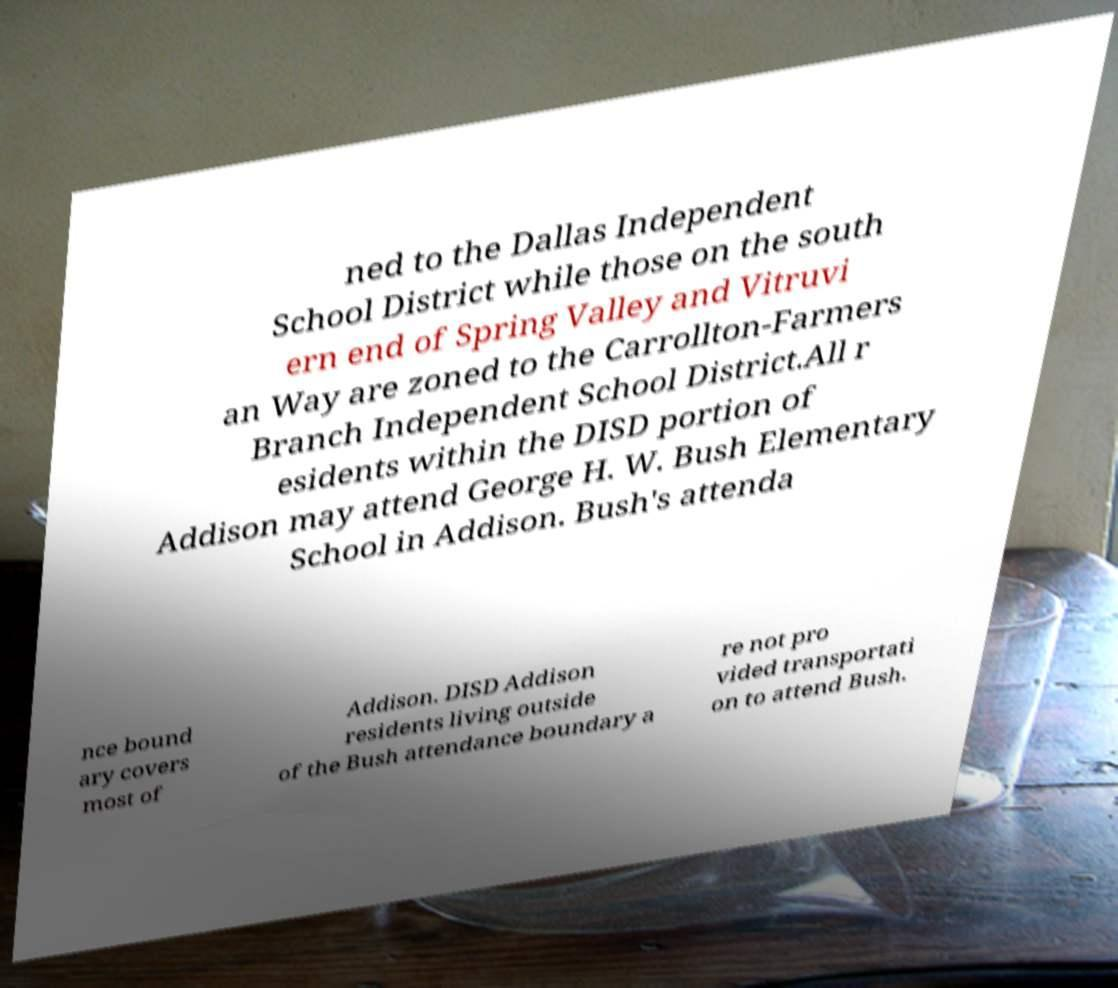Could you extract and type out the text from this image? ned to the Dallas Independent School District while those on the south ern end of Spring Valley and Vitruvi an Way are zoned to the Carrollton-Farmers Branch Independent School District.All r esidents within the DISD portion of Addison may attend George H. W. Bush Elementary School in Addison. Bush's attenda nce bound ary covers most of Addison. DISD Addison residents living outside of the Bush attendance boundary a re not pro vided transportati on to attend Bush. 